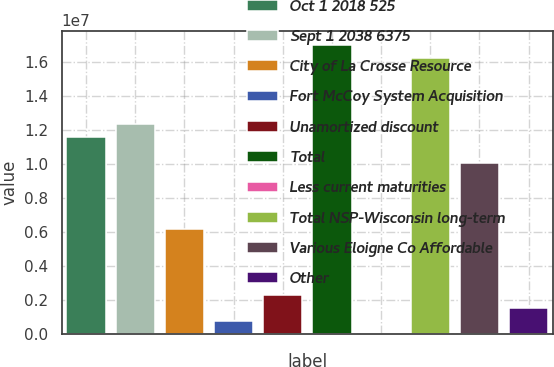Convert chart. <chart><loc_0><loc_0><loc_500><loc_500><bar_chart><fcel>Oct 1 2018 525<fcel>Sept 1 2038 6375<fcel>City of La Crosse Resource<fcel>Fort McCoy System Acquisition<fcel>Unamortized discount<fcel>Total<fcel>Less current maturities<fcel>Total NSP-Wisconsin long-term<fcel>Various Eloigne Co Affordable<fcel>Other<nl><fcel>1.15975e+07<fcel>1.23707e+07<fcel>6.18536e+06<fcel>773199<fcel>2.31953e+06<fcel>1.70097e+07<fcel>34<fcel>1.62365e+07<fcel>1.00512e+07<fcel>1.54636e+06<nl></chart> 